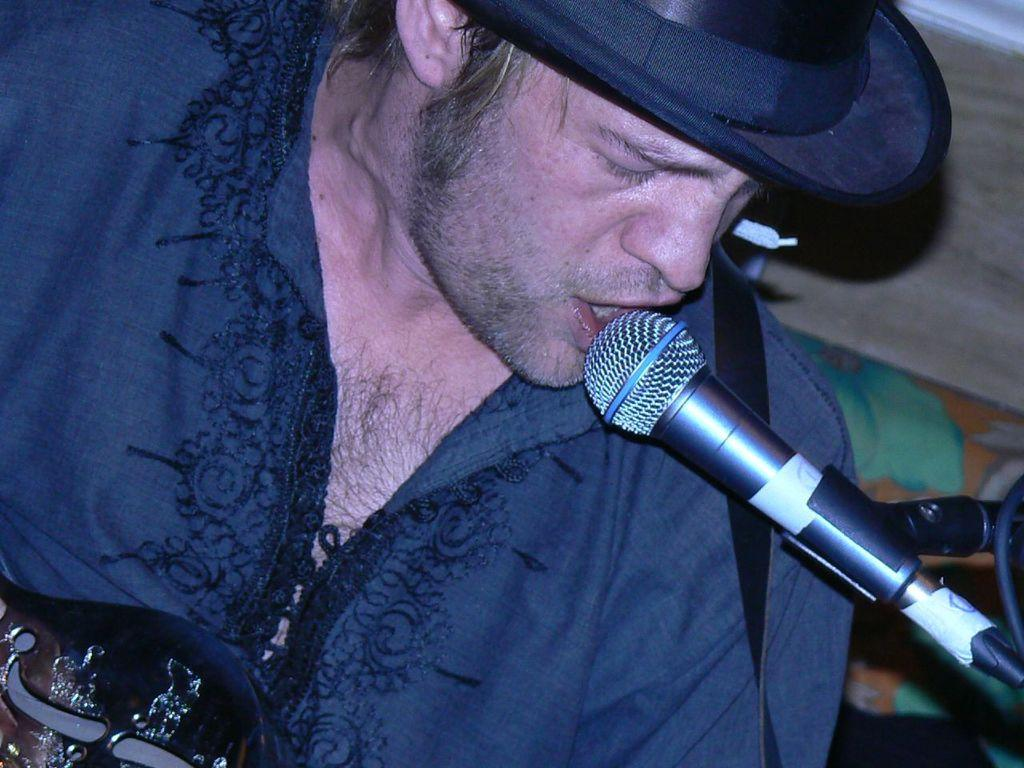What is the main subject of the image? There is a person in the image. What is the person doing in the image? The person is singing a song. What object is the person holding in the image? The person is holding a microphone. What type of accessory is the person wearing in the image? The person is wearing a hat. How many flowers are being used to tie a knot in the image? There are no flowers or knots present in the image. 